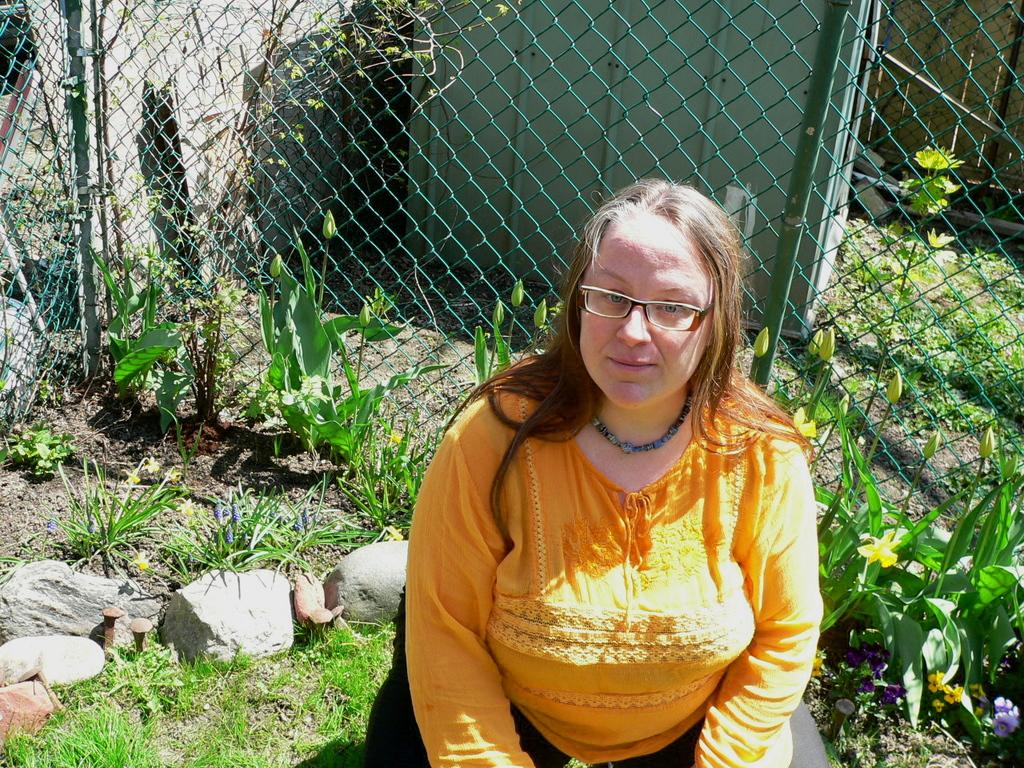Who is the main subject in the image? There is a woman in the center of the image. What can be seen in the background of the image? There is a net, a container, plants, grass, and rocks in the background of the image. What type of chalk is being used by the woman in the image? There is no chalk present in the image, and the woman is not using any chalk. What type of poison is visible in the container in the background of the image? There is no poison present in the image, and the container in the background does not contain any poison. 